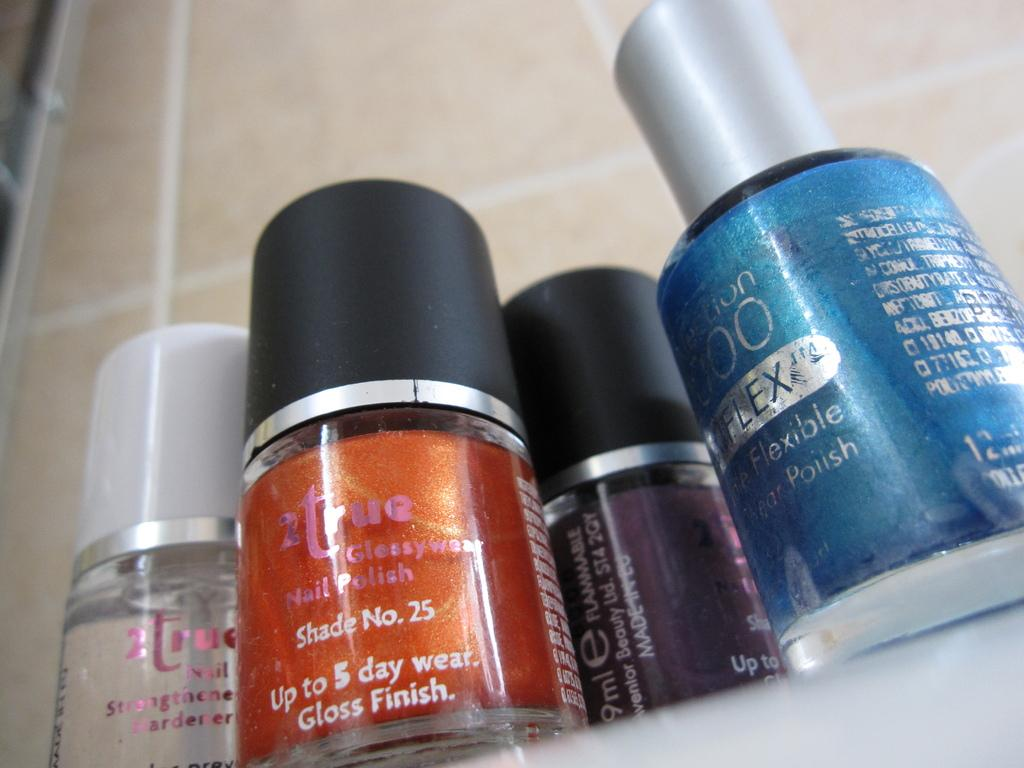<image>
Render a clear and concise summary of the photo. Bottles of nail polish with one that says Shade number 25. 